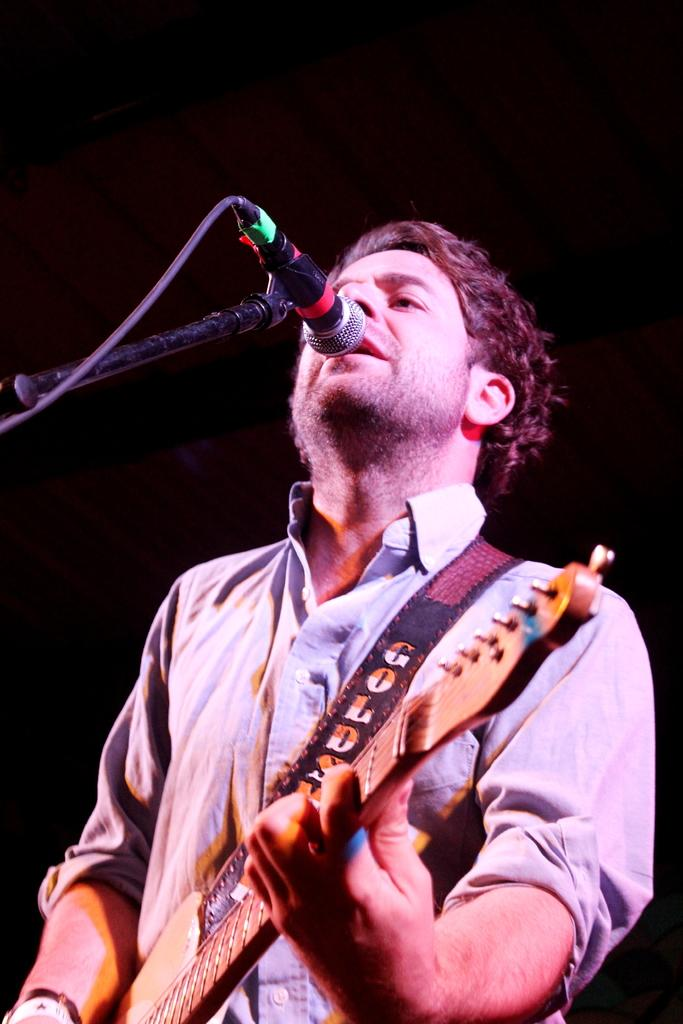What is the main subject of the image? The main subject of the image is a man. What is the man doing in the image? The man is standing, playing the guitar, and singing a song. What object is in front of the man? There is a microphone in front of the man. What is the color of the background in the image? The background of the image is black. Are there any cherries on the guitar strings in the image? There are no cherries present in the image, and they are not on the guitar strings. Can you see the man's uncle playing the guitar with him in the image? There is no mention of an uncle in the image, and only one man is visible. 